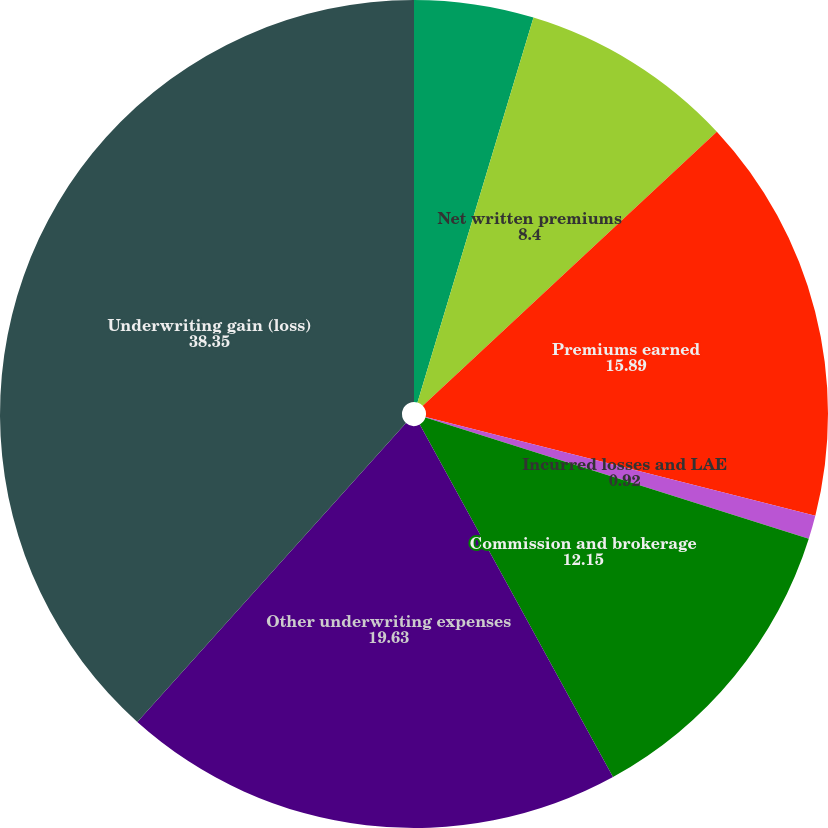<chart> <loc_0><loc_0><loc_500><loc_500><pie_chart><fcel>Gross written premiums<fcel>Net written premiums<fcel>Premiums earned<fcel>Incurred losses and LAE<fcel>Commission and brokerage<fcel>Other underwriting expenses<fcel>Underwriting gain (loss)<nl><fcel>4.66%<fcel>8.4%<fcel>15.89%<fcel>0.92%<fcel>12.15%<fcel>19.63%<fcel>38.35%<nl></chart> 